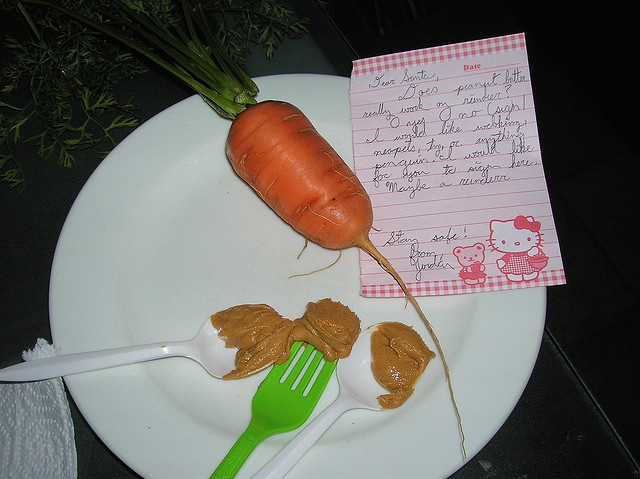Describe the objects in this image and their specific colors. I can see carrot in black, brown, red, and gray tones, fork in black and green tones, spoon in black, darkgray, and lightgray tones, and spoon in black, darkgray, and lightgray tones in this image. 